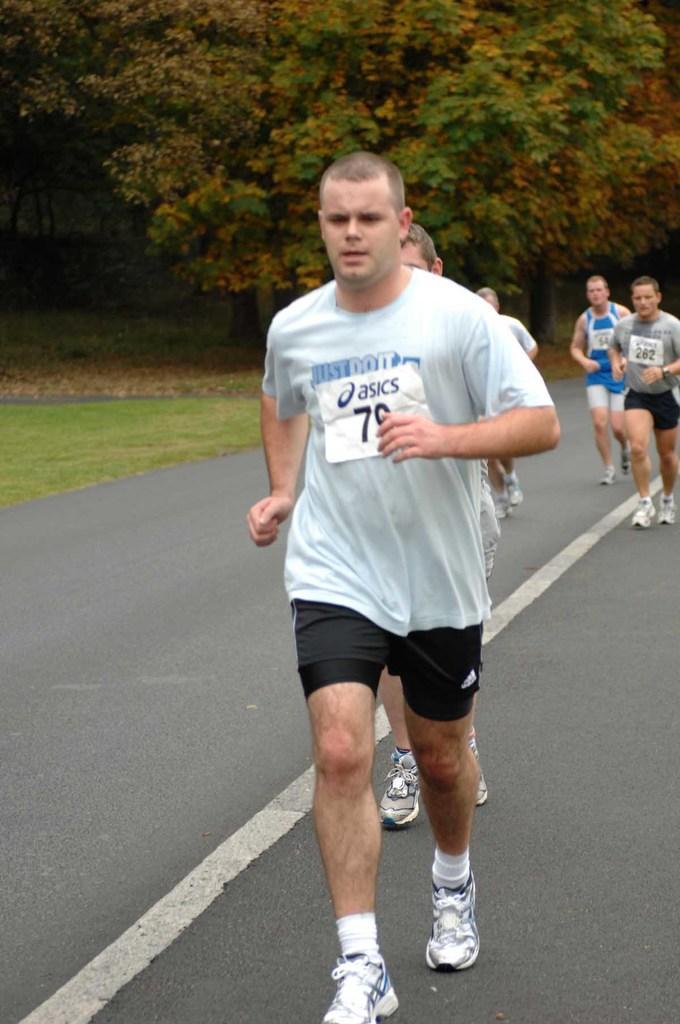Can you describe this image briefly? In this picture i can see a group of men are running on the road. These men are wearing t shirts, shorts and shoes. In the background i can see trees, grass and white color line on road. 